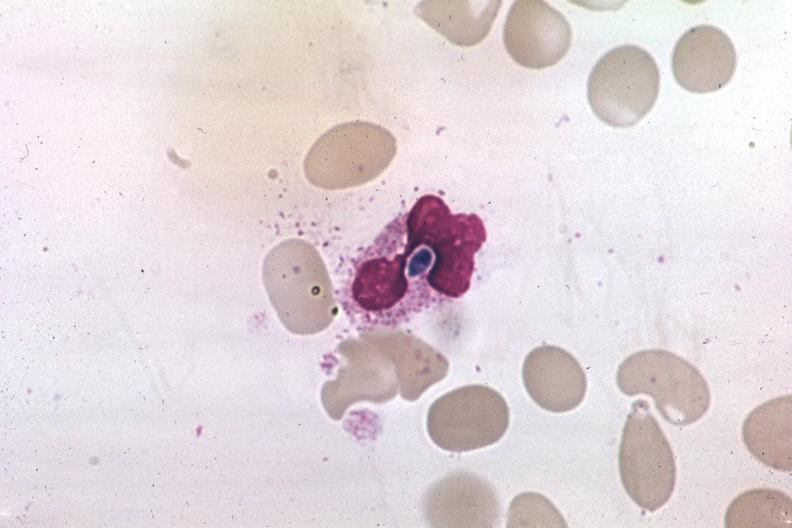does wound show wrights yeast form in a neutrophil?
Answer the question using a single word or phrase. No 